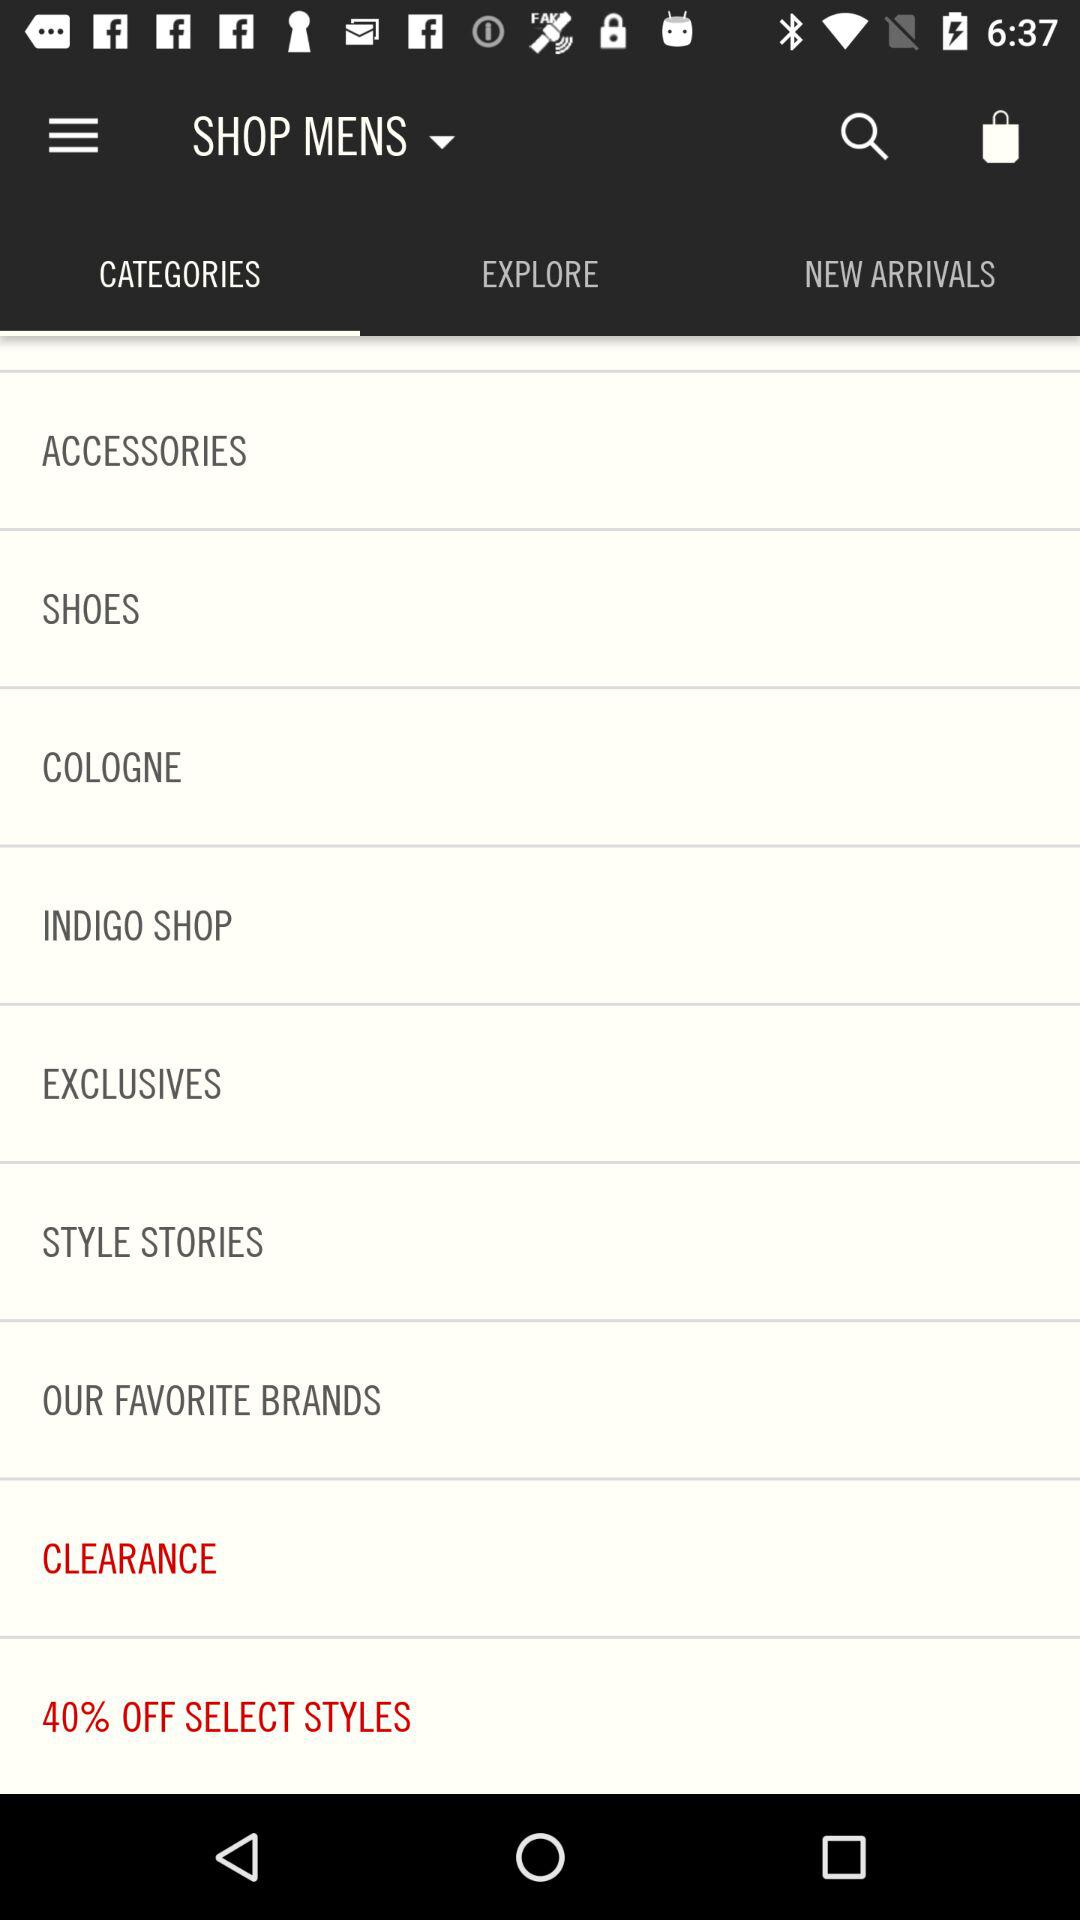What are the different types of categories for men to shop? The different categories are "ACCESSORIES", "SHOES", "COLOGNE", "INDIGO SHOP", "EXCLUSIVES", "STYLE STORIES", "OUR FAVORITE BRANDS", "CLEARANCE" and "40% OFF SELECT STYLES". 